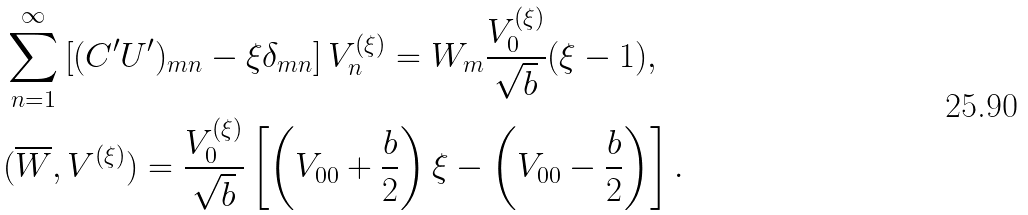<formula> <loc_0><loc_0><loc_500><loc_500>& \sum _ { n = 1 } ^ { \infty } \left [ ( C ^ { \prime } U ^ { \prime } ) _ { m n } - \xi \delta _ { m n } \right ] V _ { n } ^ { ( \xi ) } = W _ { m } \frac { V _ { 0 } ^ { ( \xi ) } } { \sqrt { b } } ( \xi - 1 ) , \\ & ( \overline { W } , V ^ { ( \xi ) } ) = \frac { V _ { 0 } ^ { ( \xi ) } } { \sqrt { b } } \left [ \left ( V _ { 0 0 } + \frac { b } { 2 } \right ) \xi - \left ( V _ { 0 0 } - \frac { b } { 2 } \right ) \right ] .</formula> 